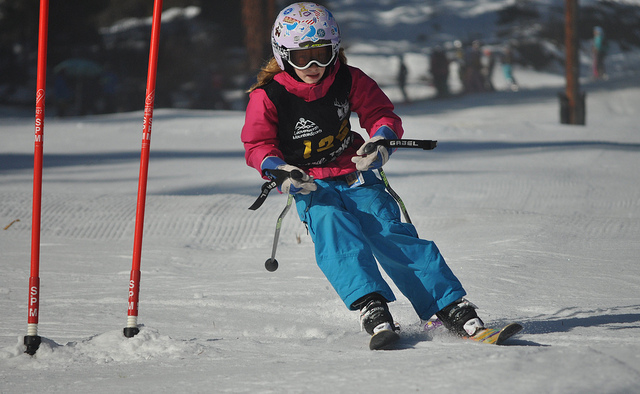<image>Is this person moving fast? I don't know if the person is moving fast. The response could both be yes and no. Is this person moving fast? I don't know if the person is moving fast. It can be both yes and no. 